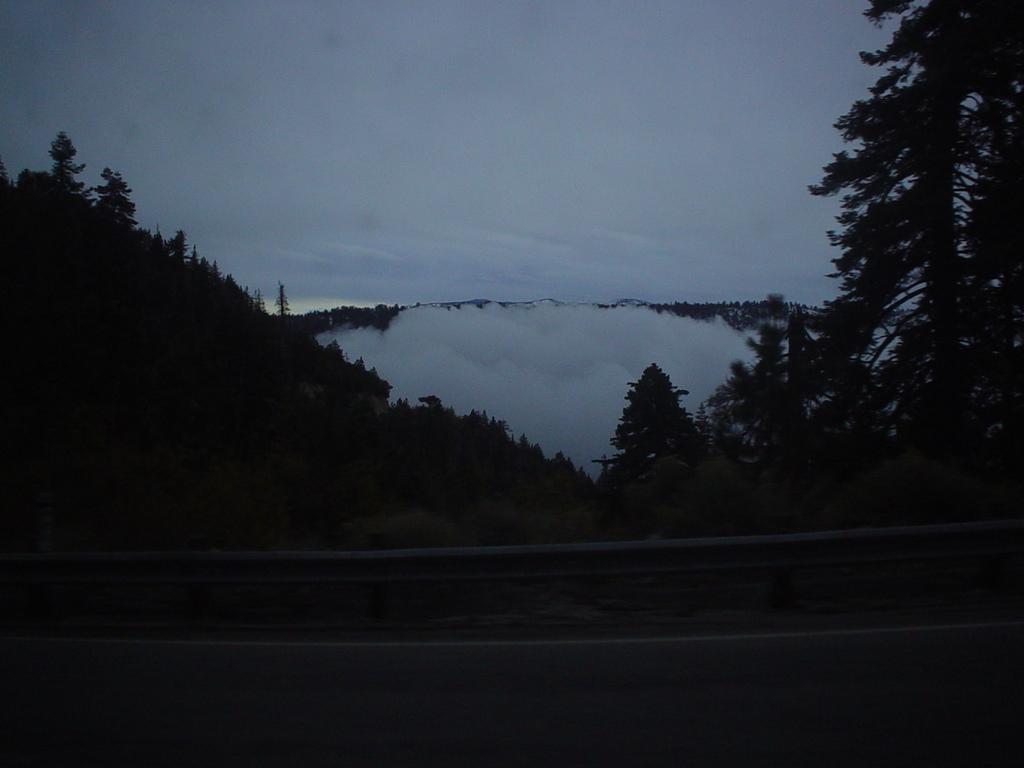Describe this image in one or two sentences. In this picture there are trees on the mountain. At the top there is sky and there are clouds. At the bottom there is a road and there is a railing beside the road. 